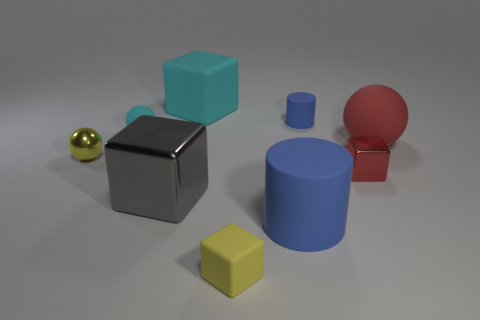What size is the matte thing that is the same color as the tiny matte cylinder?
Provide a short and direct response. Large. Are there the same number of large blue objects right of the big red ball and red objects behind the large cyan block?
Ensure brevity in your answer.  Yes. There is a red matte thing; is its shape the same as the small matte object that is in front of the tiny matte ball?
Provide a short and direct response. No. There is a object that is the same color as the big matte cylinder; what material is it?
Your answer should be very brief. Rubber. Is there any other thing that has the same shape as the red rubber thing?
Ensure brevity in your answer.  Yes. Is the material of the tiny cylinder the same as the ball that is on the right side of the tiny matte cube?
Give a very brief answer. Yes. What color is the big block that is behind the rubber cylinder to the right of the blue object to the left of the small blue cylinder?
Provide a short and direct response. Cyan. Is there any other thing that has the same size as the red rubber thing?
Provide a short and direct response. Yes. There is a large rubber cylinder; does it have the same color as the matte cylinder on the right side of the big matte cylinder?
Give a very brief answer. Yes. The large cylinder is what color?
Make the answer very short. Blue. 